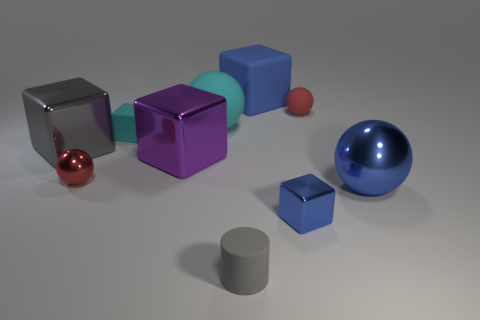There is a big rubber object that is the same color as the tiny metal cube; what is its shape?
Keep it short and to the point. Cube. There is a shiny cube that is the same color as the tiny rubber cylinder; what is its size?
Keep it short and to the point. Large. Is there a thing that has the same material as the purple block?
Give a very brief answer. Yes. There is a large shiny thing that is left of the tiny gray matte object and right of the gray metal object; what shape is it?
Offer a terse response. Cube. What number of other things are the same shape as the tiny blue shiny object?
Your answer should be compact. 4. The gray shiny cube has what size?
Provide a succinct answer. Large. How many things are big red rubber cubes or small spheres?
Give a very brief answer. 2. How big is the red thing that is on the left side of the large rubber block?
Offer a very short reply. Small. There is a tiny rubber thing that is behind the large blue shiny ball and to the left of the small red matte sphere; what is its color?
Ensure brevity in your answer.  Cyan. Do the small red ball right of the blue matte object and the big blue block have the same material?
Provide a short and direct response. Yes. 